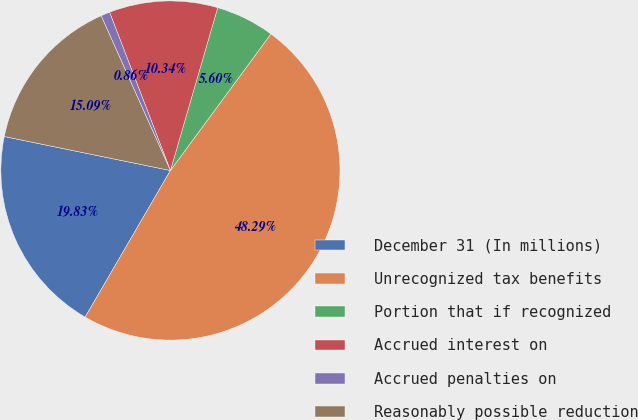<chart> <loc_0><loc_0><loc_500><loc_500><pie_chart><fcel>December 31 (In millions)<fcel>Unrecognized tax benefits<fcel>Portion that if recognized<fcel>Accrued interest on<fcel>Accrued penalties on<fcel>Reasonably possible reduction<nl><fcel>19.83%<fcel>48.29%<fcel>5.6%<fcel>10.34%<fcel>0.86%<fcel>15.09%<nl></chart> 